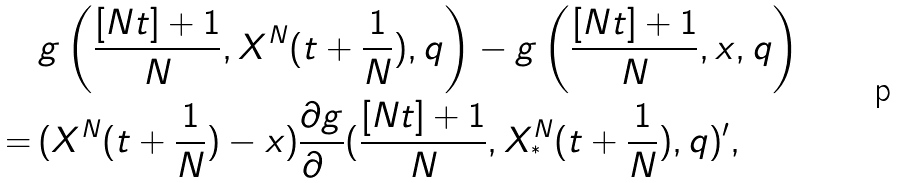Convert formula to latex. <formula><loc_0><loc_0><loc_500><loc_500>& \, g \left ( \frac { [ N t ] + 1 } { N } , X ^ { N } ( t + \frac { 1 } { N } ) , q \right ) - g \left ( \frac { [ N t ] + 1 } { N } , x , q \right ) \\ = & \, ( X ^ { N } ( t + \frac { 1 } { N } ) - x ) \frac { \partial g } { \partial { \mathbf x } } ( \frac { [ N t ] + 1 } { N } , X ^ { N } _ { ^ { * } } ( t + \frac { 1 } { N } ) , q ) ^ { \prime } ,</formula> 